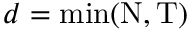<formula> <loc_0><loc_0><loc_500><loc_500>d = \min ( N , T )</formula> 